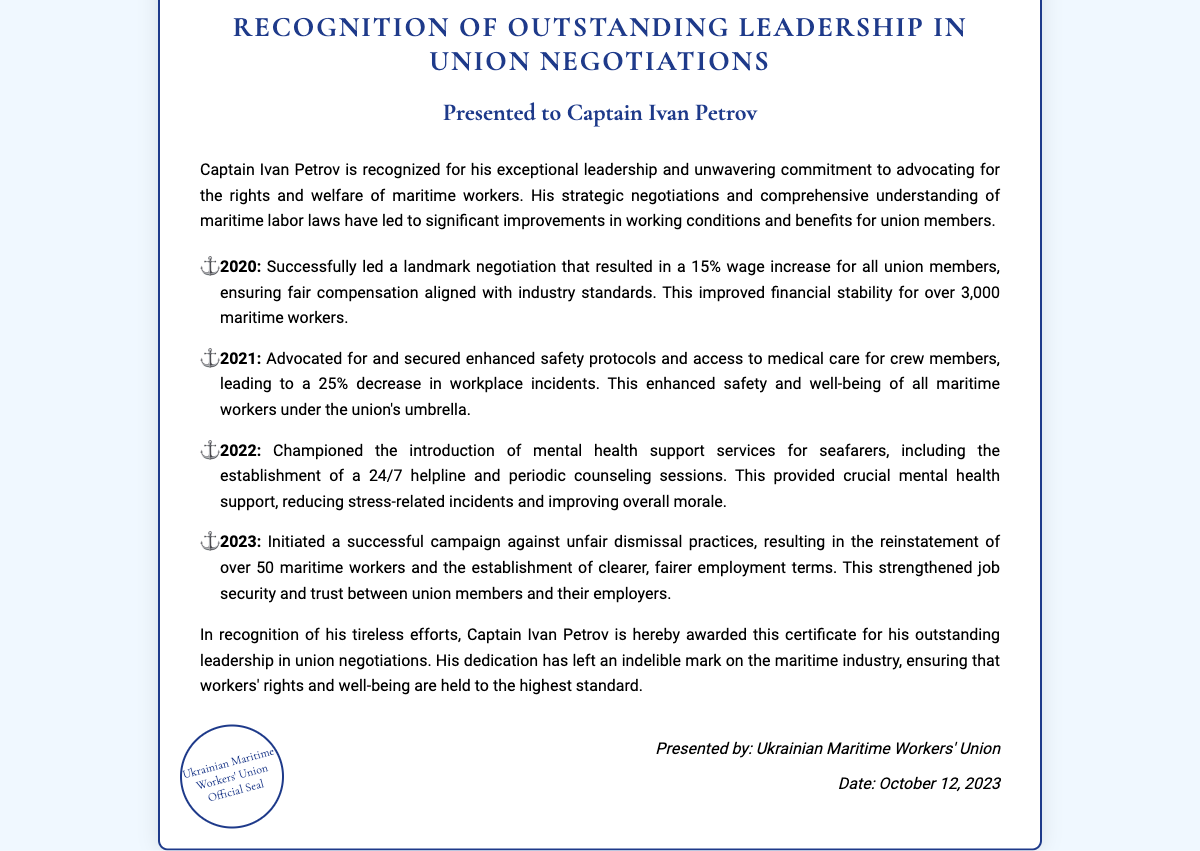What is the name of the individual recognized in the certificate? The document specifically names the individual as "Captain Ivan Petrov."
Answer: Captain Ivan Petrov What organization presented the certificate? The certificate states it was presented by the "Ukrainian Maritime Workers' Union."
Answer: Ukrainian Maritime Workers' Union What year did Captain Ivan Petrov lead the negotiation for a 15% wage increase? The document highlights the year 2020 for the wage increase negotiation.
Answer: 2020 How much did workplace incidents decrease in 2021? The document mentions a 25% decrease in workplace incidents in 2021 following enhanced safety protocols.
Answer: 25% What was introduced in 2022 to support seafarers' mental health? The document notes the establishment of a "24/7 helpline" as mental health support for seafarers.
Answer: 24/7 helpline How many maritime workers were reinstated in 2023 due to Captain Petrov's campaign? The certificate states that over 50 maritime workers were reinstated.
Answer: Over 50 What was the date on the certificate? The document specifies the date as "October 12, 2023."
Answer: October 12, 2023 What phrase is used to describe Captain Ivan Petrov's leadership contributions? The document mentions "outstanding leadership in union negotiations" to highlight his contributions.
Answer: Outstanding leadership in union negotiations What type of improvements did the negotiations primarily focus on? The document indicates that the negotiations focused on the rights and welfare of maritime workers.
Answer: Rights and welfare of maritime workers 